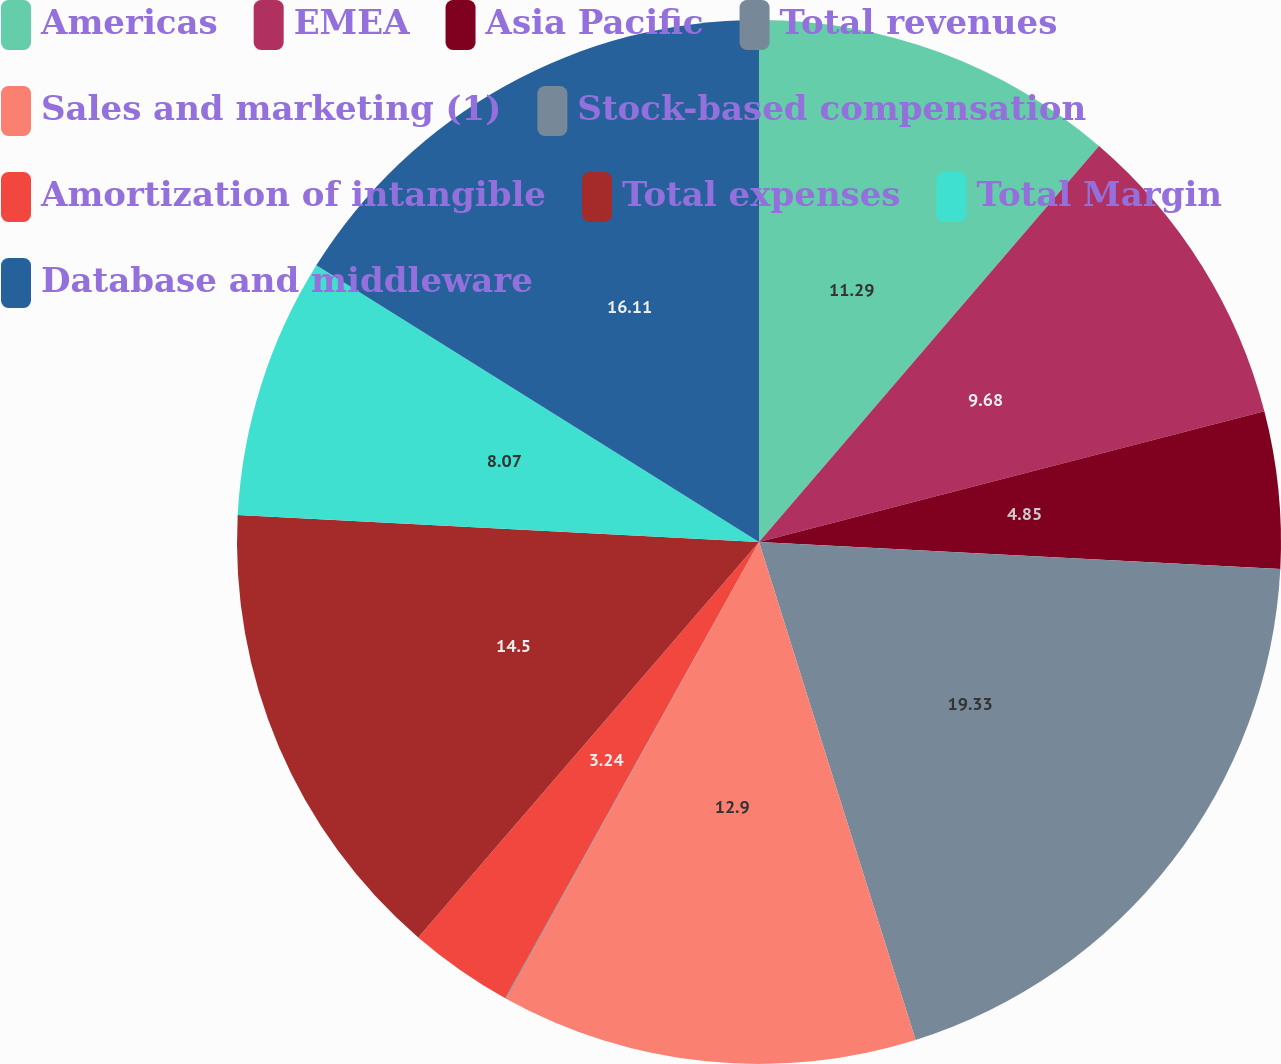Convert chart. <chart><loc_0><loc_0><loc_500><loc_500><pie_chart><fcel>Americas<fcel>EMEA<fcel>Asia Pacific<fcel>Total revenues<fcel>Sales and marketing (1)<fcel>Stock-based compensation<fcel>Amortization of intangible<fcel>Total expenses<fcel>Total Margin<fcel>Database and middleware<nl><fcel>11.29%<fcel>9.68%<fcel>4.85%<fcel>19.33%<fcel>12.9%<fcel>0.03%<fcel>3.24%<fcel>14.5%<fcel>8.07%<fcel>16.11%<nl></chart> 